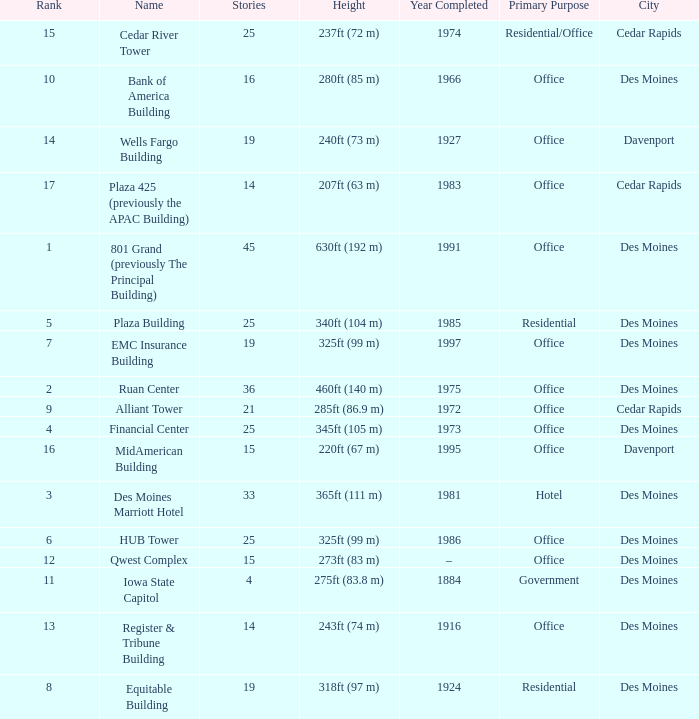What is the height of the EMC Insurance Building in Des Moines? 325ft (99 m). 